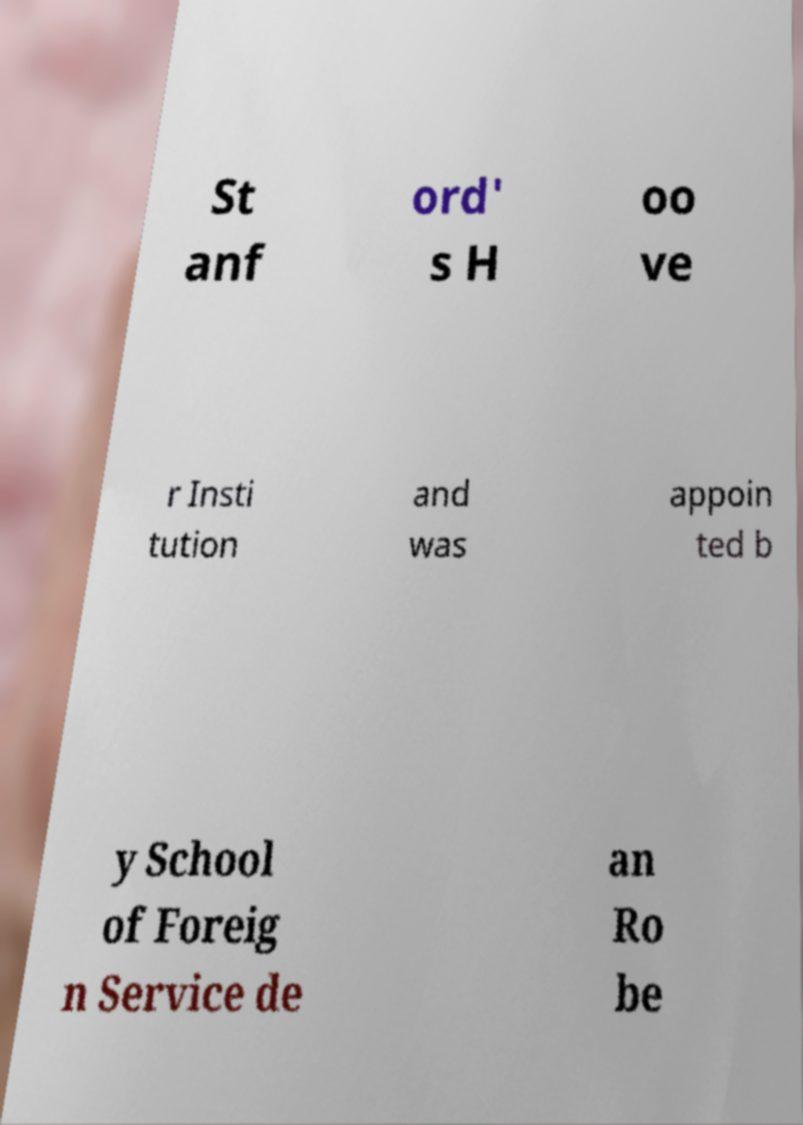What messages or text are displayed in this image? I need them in a readable, typed format. St anf ord' s H oo ve r Insti tution and was appoin ted b y School of Foreig n Service de an Ro be 